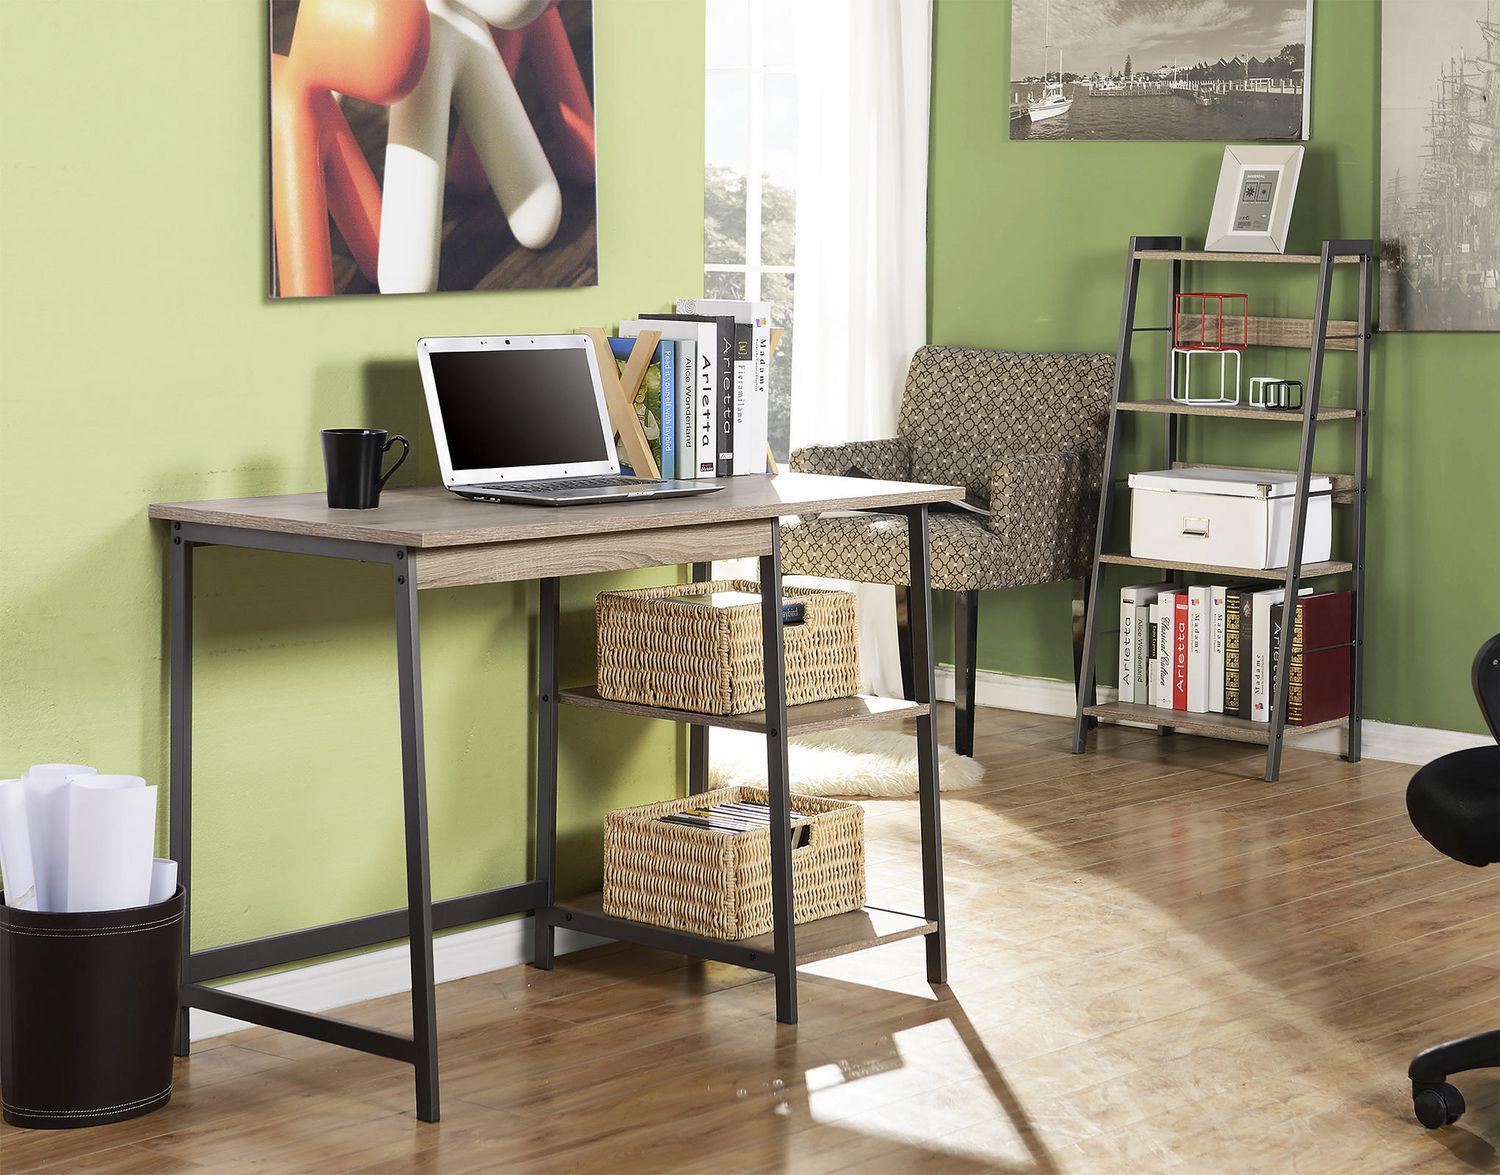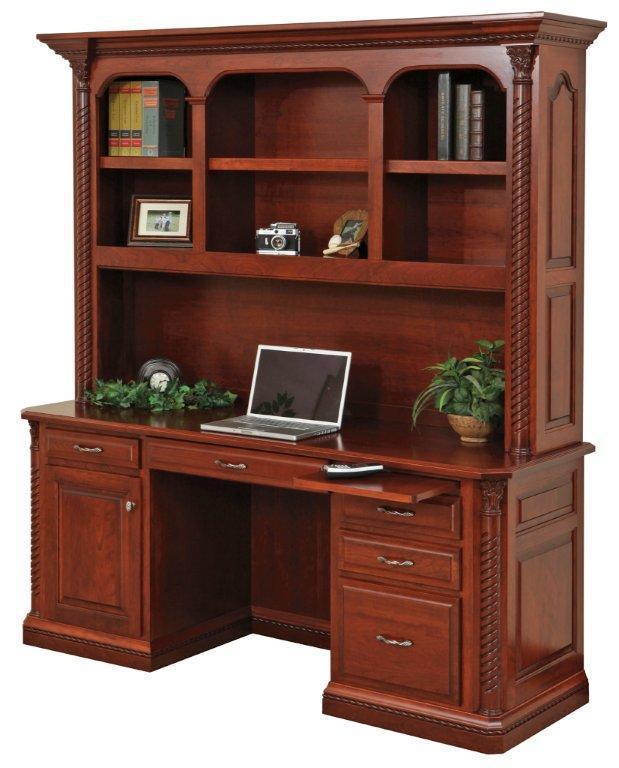The first image is the image on the left, the second image is the image on the right. Given the left and right images, does the statement "In one image a leather chair is placed at a desk unit that is attached and perpendicular to a large bookcase." hold true? Answer yes or no. No. The first image is the image on the left, the second image is the image on the right. Examine the images to the left and right. Is the description "One image includes a simple gray desk with open shelves underneath and a matching slant-front set of shelves that resembles a ladder." accurate? Answer yes or no. Yes. 